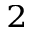<formula> <loc_0><loc_0><loc_500><loc_500>^ { 2 }</formula> 